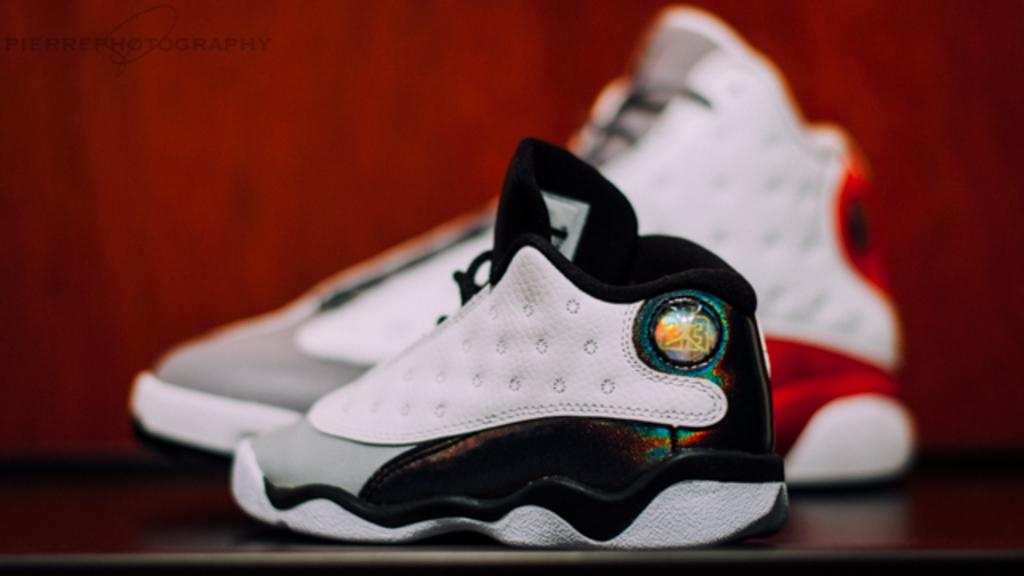What objects are present in the image? There are two shoes in the image. Where are the shoes located? The shoes are on an object. Can you describe the background of the image? The background of the image is blurred. Is there any additional information or marking on the image? Yes, there is a watermark on the image. What type of calculator can be seen in the image? There is no calculator present in the image. What event is taking place in the image? There is no event depicted in the image; it only shows two shoes on an object. 